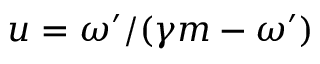<formula> <loc_0><loc_0><loc_500><loc_500>u = \omega ^ { \prime } / ( \gamma m - \omega ^ { \prime } )</formula> 